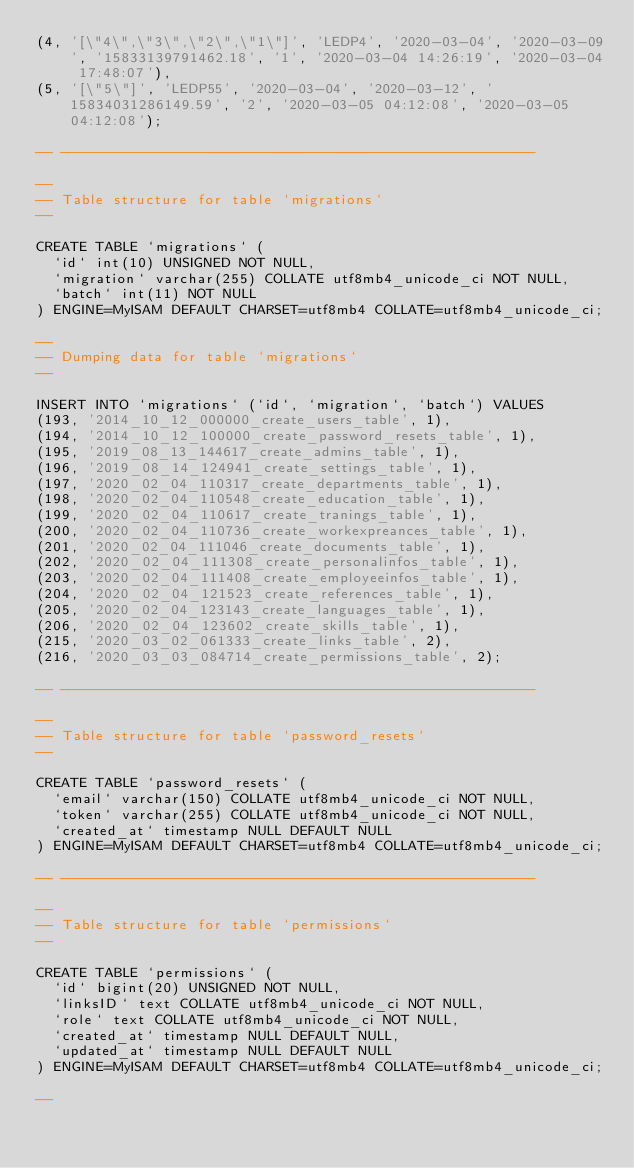<code> <loc_0><loc_0><loc_500><loc_500><_SQL_>(4, '[\"4\",\"3\",\"2\",\"1\"]', 'LEDP4', '2020-03-04', '2020-03-09', '15833139791462.18', '1', '2020-03-04 14:26:19', '2020-03-04 17:48:07'),
(5, '[\"5\"]', 'LEDP55', '2020-03-04', '2020-03-12', '15834031286149.59', '2', '2020-03-05 04:12:08', '2020-03-05 04:12:08');

-- --------------------------------------------------------

--
-- Table structure for table `migrations`
--

CREATE TABLE `migrations` (
  `id` int(10) UNSIGNED NOT NULL,
  `migration` varchar(255) COLLATE utf8mb4_unicode_ci NOT NULL,
  `batch` int(11) NOT NULL
) ENGINE=MyISAM DEFAULT CHARSET=utf8mb4 COLLATE=utf8mb4_unicode_ci;

--
-- Dumping data for table `migrations`
--

INSERT INTO `migrations` (`id`, `migration`, `batch`) VALUES
(193, '2014_10_12_000000_create_users_table', 1),
(194, '2014_10_12_100000_create_password_resets_table', 1),
(195, '2019_08_13_144617_create_admins_table', 1),
(196, '2019_08_14_124941_create_settings_table', 1),
(197, '2020_02_04_110317_create_departments_table', 1),
(198, '2020_02_04_110548_create_education_table', 1),
(199, '2020_02_04_110617_create_tranings_table', 1),
(200, '2020_02_04_110736_create_workexpreances_table', 1),
(201, '2020_02_04_111046_create_documents_table', 1),
(202, '2020_02_04_111308_create_personalinfos_table', 1),
(203, '2020_02_04_111408_create_employeeinfos_table', 1),
(204, '2020_02_04_121523_create_references_table', 1),
(205, '2020_02_04_123143_create_languages_table', 1),
(206, '2020_02_04_123602_create_skills_table', 1),
(215, '2020_03_02_061333_create_links_table', 2),
(216, '2020_03_03_084714_create_permissions_table', 2);

-- --------------------------------------------------------

--
-- Table structure for table `password_resets`
--

CREATE TABLE `password_resets` (
  `email` varchar(150) COLLATE utf8mb4_unicode_ci NOT NULL,
  `token` varchar(255) COLLATE utf8mb4_unicode_ci NOT NULL,
  `created_at` timestamp NULL DEFAULT NULL
) ENGINE=MyISAM DEFAULT CHARSET=utf8mb4 COLLATE=utf8mb4_unicode_ci;

-- --------------------------------------------------------

--
-- Table structure for table `permissions`
--

CREATE TABLE `permissions` (
  `id` bigint(20) UNSIGNED NOT NULL,
  `linksID` text COLLATE utf8mb4_unicode_ci NOT NULL,
  `role` text COLLATE utf8mb4_unicode_ci NOT NULL,
  `created_at` timestamp NULL DEFAULT NULL,
  `updated_at` timestamp NULL DEFAULT NULL
) ENGINE=MyISAM DEFAULT CHARSET=utf8mb4 COLLATE=utf8mb4_unicode_ci;

--</code> 